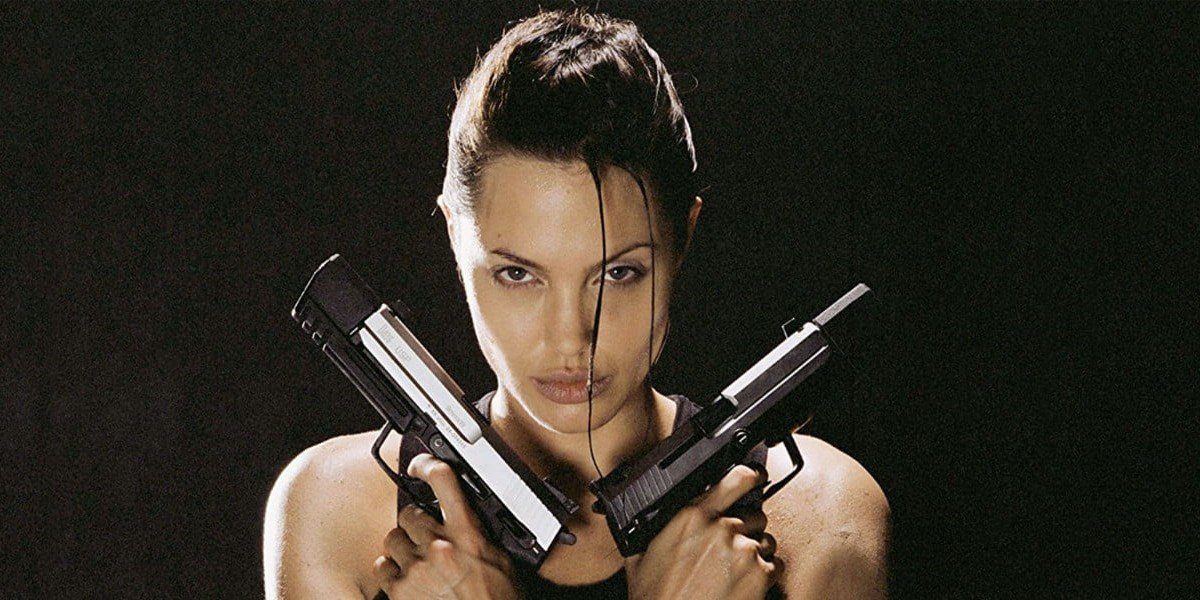Can you describe the significance of Lara Croft's outfit and what it represents in her character portrayal? Lara Croft's outfit, especially her black tank top and combat trousers, is not only practical for her adventurous pursuits but also symbolizes her no-nonsense approach to challenges. The simplicity and functionality of her attire reflect her readiness and capability to navigate through dangerous and unpredictable environments. This minimalist approach emphasizes her strength and independence, central themes to her character that have inspired many as a symbol of female empowerment in video games and movies. 